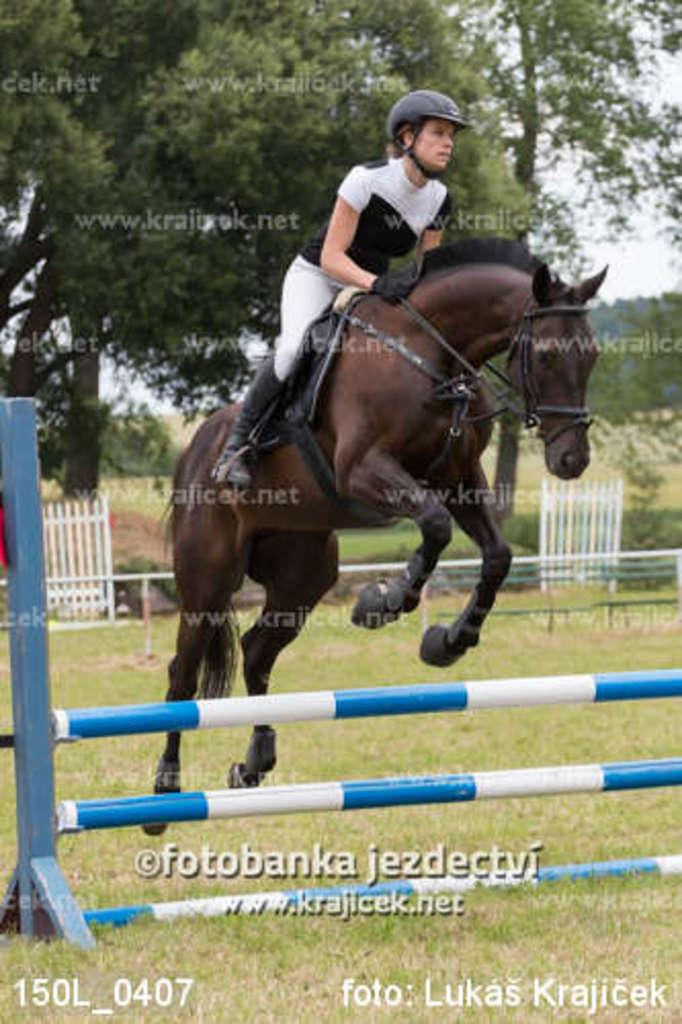What type of vegetation can be seen in the image? There are trees in the image. What activity is the person in the image engaged in? There is a person riding a horse in the image. What obstacle is present in the image? There is a hurdle in the image. What can be found at the bottom of the image? There is some text at the bottom of the image. What type of coal is being used by the doctor in the image? There is no doctor or coal present in the image. How does the person in the image care for the trees? The image does not show any interaction between the person and the trees, so it cannot be determined how the person cares for them. 